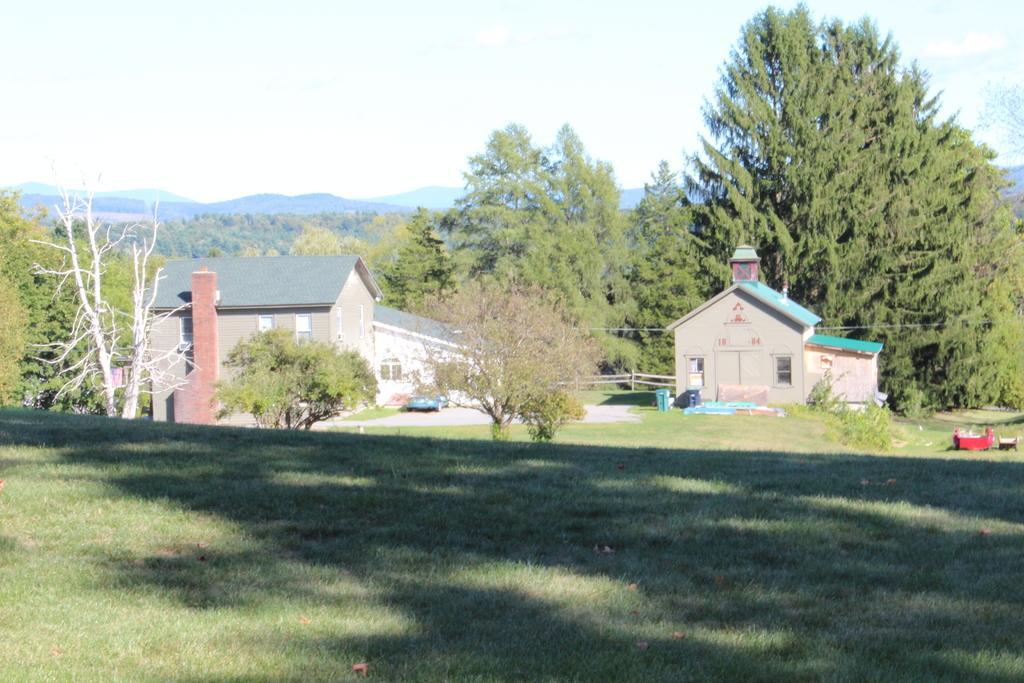Could you give a brief overview of what you see in this image? In this picture I can see few buildings, trees and I can see grass on the ground and I can see hills and a cloudy sky and I can see a dustbin and I can see few plants and grass on the ground. 